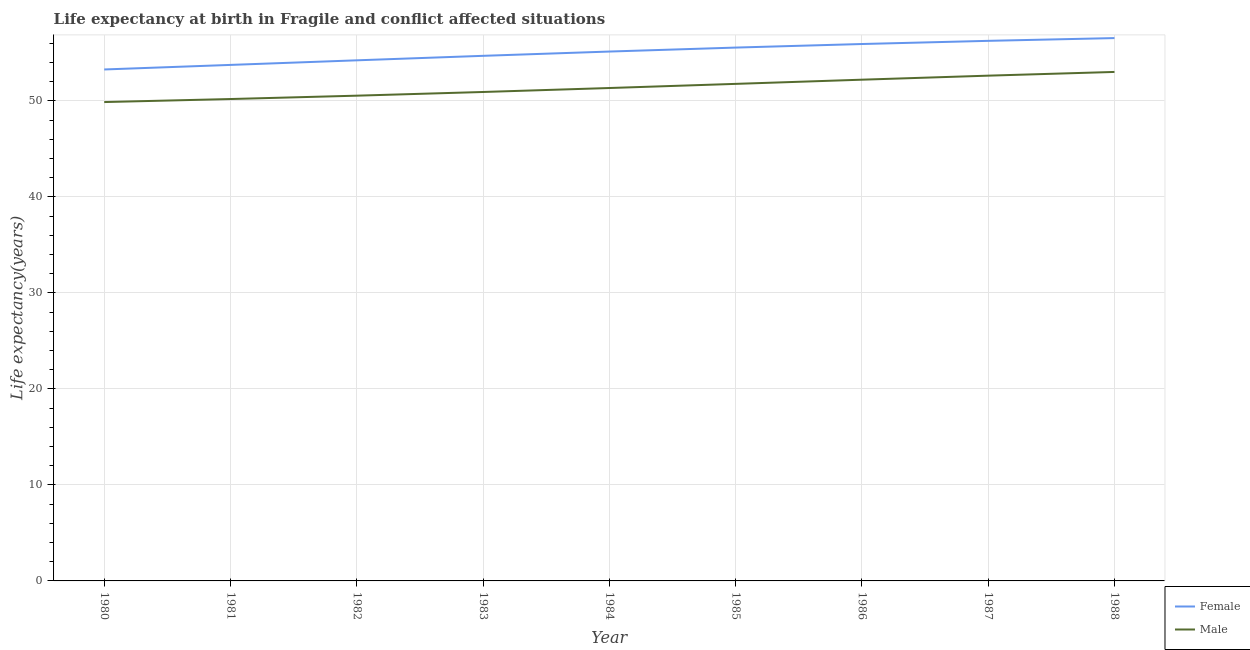How many different coloured lines are there?
Your answer should be very brief. 2. Is the number of lines equal to the number of legend labels?
Your answer should be compact. Yes. What is the life expectancy(female) in 1986?
Keep it short and to the point. 55.92. Across all years, what is the maximum life expectancy(male)?
Your response must be concise. 53.01. Across all years, what is the minimum life expectancy(male)?
Ensure brevity in your answer.  49.88. In which year was the life expectancy(male) maximum?
Your answer should be very brief. 1988. What is the total life expectancy(male) in the graph?
Keep it short and to the point. 462.5. What is the difference between the life expectancy(male) in 1980 and that in 1983?
Ensure brevity in your answer.  -1.05. What is the difference between the life expectancy(male) in 1988 and the life expectancy(female) in 1986?
Give a very brief answer. -2.91. What is the average life expectancy(female) per year?
Your response must be concise. 55.04. In the year 1981, what is the difference between the life expectancy(male) and life expectancy(female)?
Ensure brevity in your answer.  -3.55. In how many years, is the life expectancy(male) greater than 10 years?
Give a very brief answer. 9. What is the ratio of the life expectancy(male) in 1982 to that in 1985?
Your answer should be very brief. 0.98. Is the life expectancy(male) in 1983 less than that in 1988?
Your answer should be compact. Yes. What is the difference between the highest and the second highest life expectancy(female)?
Provide a succinct answer. 0.29. What is the difference between the highest and the lowest life expectancy(female)?
Provide a short and direct response. 3.27. In how many years, is the life expectancy(male) greater than the average life expectancy(male) taken over all years?
Make the answer very short. 4. Is the sum of the life expectancy(male) in 1980 and 1981 greater than the maximum life expectancy(female) across all years?
Offer a very short reply. Yes. Does the life expectancy(female) monotonically increase over the years?
Your response must be concise. Yes. Is the life expectancy(female) strictly greater than the life expectancy(male) over the years?
Keep it short and to the point. Yes. Is the life expectancy(male) strictly less than the life expectancy(female) over the years?
Your answer should be compact. Yes. Does the graph contain grids?
Make the answer very short. Yes. How are the legend labels stacked?
Make the answer very short. Vertical. What is the title of the graph?
Ensure brevity in your answer.  Life expectancy at birth in Fragile and conflict affected situations. What is the label or title of the X-axis?
Give a very brief answer. Year. What is the label or title of the Y-axis?
Provide a succinct answer. Life expectancy(years). What is the Life expectancy(years) of Female in 1980?
Your answer should be very brief. 53.27. What is the Life expectancy(years) of Male in 1980?
Your response must be concise. 49.88. What is the Life expectancy(years) in Female in 1981?
Give a very brief answer. 53.75. What is the Life expectancy(years) in Male in 1981?
Keep it short and to the point. 50.19. What is the Life expectancy(years) in Female in 1982?
Ensure brevity in your answer.  54.23. What is the Life expectancy(years) of Male in 1982?
Offer a terse response. 50.54. What is the Life expectancy(years) in Female in 1983?
Make the answer very short. 54.69. What is the Life expectancy(years) in Male in 1983?
Provide a short and direct response. 50.93. What is the Life expectancy(years) in Female in 1984?
Your answer should be compact. 55.14. What is the Life expectancy(years) of Male in 1984?
Make the answer very short. 51.34. What is the Life expectancy(years) of Female in 1985?
Offer a terse response. 55.55. What is the Life expectancy(years) of Male in 1985?
Keep it short and to the point. 51.77. What is the Life expectancy(years) of Female in 1986?
Provide a succinct answer. 55.92. What is the Life expectancy(years) in Male in 1986?
Your answer should be very brief. 52.21. What is the Life expectancy(years) in Female in 1987?
Ensure brevity in your answer.  56.25. What is the Life expectancy(years) of Male in 1987?
Make the answer very short. 52.63. What is the Life expectancy(years) in Female in 1988?
Ensure brevity in your answer.  56.54. What is the Life expectancy(years) of Male in 1988?
Offer a terse response. 53.01. Across all years, what is the maximum Life expectancy(years) of Female?
Ensure brevity in your answer.  56.54. Across all years, what is the maximum Life expectancy(years) in Male?
Offer a terse response. 53.01. Across all years, what is the minimum Life expectancy(years) in Female?
Make the answer very short. 53.27. Across all years, what is the minimum Life expectancy(years) in Male?
Make the answer very short. 49.88. What is the total Life expectancy(years) in Female in the graph?
Give a very brief answer. 495.35. What is the total Life expectancy(years) in Male in the graph?
Your answer should be very brief. 462.5. What is the difference between the Life expectancy(years) in Female in 1980 and that in 1981?
Your response must be concise. -0.48. What is the difference between the Life expectancy(years) in Male in 1980 and that in 1981?
Provide a short and direct response. -0.32. What is the difference between the Life expectancy(years) of Female in 1980 and that in 1982?
Offer a very short reply. -0.95. What is the difference between the Life expectancy(years) of Male in 1980 and that in 1982?
Keep it short and to the point. -0.67. What is the difference between the Life expectancy(years) of Female in 1980 and that in 1983?
Provide a succinct answer. -1.42. What is the difference between the Life expectancy(years) of Male in 1980 and that in 1983?
Your answer should be very brief. -1.05. What is the difference between the Life expectancy(years) of Female in 1980 and that in 1984?
Offer a terse response. -1.87. What is the difference between the Life expectancy(years) in Male in 1980 and that in 1984?
Make the answer very short. -1.46. What is the difference between the Life expectancy(years) in Female in 1980 and that in 1985?
Provide a succinct answer. -2.28. What is the difference between the Life expectancy(years) of Male in 1980 and that in 1985?
Make the answer very short. -1.9. What is the difference between the Life expectancy(years) in Female in 1980 and that in 1986?
Offer a very short reply. -2.65. What is the difference between the Life expectancy(years) of Male in 1980 and that in 1986?
Ensure brevity in your answer.  -2.33. What is the difference between the Life expectancy(years) of Female in 1980 and that in 1987?
Offer a very short reply. -2.98. What is the difference between the Life expectancy(years) of Male in 1980 and that in 1987?
Keep it short and to the point. -2.75. What is the difference between the Life expectancy(years) of Female in 1980 and that in 1988?
Make the answer very short. -3.27. What is the difference between the Life expectancy(years) in Male in 1980 and that in 1988?
Offer a terse response. -3.14. What is the difference between the Life expectancy(years) of Female in 1981 and that in 1982?
Give a very brief answer. -0.48. What is the difference between the Life expectancy(years) of Male in 1981 and that in 1982?
Offer a very short reply. -0.35. What is the difference between the Life expectancy(years) of Female in 1981 and that in 1983?
Offer a terse response. -0.95. What is the difference between the Life expectancy(years) of Male in 1981 and that in 1983?
Your answer should be very brief. -0.73. What is the difference between the Life expectancy(years) of Female in 1981 and that in 1984?
Your response must be concise. -1.39. What is the difference between the Life expectancy(years) of Male in 1981 and that in 1984?
Offer a very short reply. -1.15. What is the difference between the Life expectancy(years) in Female in 1981 and that in 1985?
Provide a succinct answer. -1.8. What is the difference between the Life expectancy(years) of Male in 1981 and that in 1985?
Make the answer very short. -1.58. What is the difference between the Life expectancy(years) of Female in 1981 and that in 1986?
Give a very brief answer. -2.18. What is the difference between the Life expectancy(years) in Male in 1981 and that in 1986?
Give a very brief answer. -2.01. What is the difference between the Life expectancy(years) in Female in 1981 and that in 1987?
Ensure brevity in your answer.  -2.51. What is the difference between the Life expectancy(years) in Male in 1981 and that in 1987?
Offer a terse response. -2.43. What is the difference between the Life expectancy(years) in Female in 1981 and that in 1988?
Offer a terse response. -2.79. What is the difference between the Life expectancy(years) in Male in 1981 and that in 1988?
Provide a succinct answer. -2.82. What is the difference between the Life expectancy(years) of Female in 1982 and that in 1983?
Your response must be concise. -0.47. What is the difference between the Life expectancy(years) of Male in 1982 and that in 1983?
Offer a terse response. -0.38. What is the difference between the Life expectancy(years) of Female in 1982 and that in 1984?
Offer a terse response. -0.91. What is the difference between the Life expectancy(years) in Male in 1982 and that in 1984?
Your answer should be compact. -0.8. What is the difference between the Life expectancy(years) in Female in 1982 and that in 1985?
Offer a terse response. -1.33. What is the difference between the Life expectancy(years) of Male in 1982 and that in 1985?
Keep it short and to the point. -1.23. What is the difference between the Life expectancy(years) of Female in 1982 and that in 1986?
Ensure brevity in your answer.  -1.7. What is the difference between the Life expectancy(years) of Male in 1982 and that in 1986?
Offer a terse response. -1.67. What is the difference between the Life expectancy(years) in Female in 1982 and that in 1987?
Provide a short and direct response. -2.03. What is the difference between the Life expectancy(years) of Male in 1982 and that in 1987?
Give a very brief answer. -2.09. What is the difference between the Life expectancy(years) in Female in 1982 and that in 1988?
Your answer should be very brief. -2.32. What is the difference between the Life expectancy(years) in Male in 1982 and that in 1988?
Give a very brief answer. -2.47. What is the difference between the Life expectancy(years) in Female in 1983 and that in 1984?
Provide a short and direct response. -0.45. What is the difference between the Life expectancy(years) in Male in 1983 and that in 1984?
Keep it short and to the point. -0.41. What is the difference between the Life expectancy(years) in Female in 1983 and that in 1985?
Your response must be concise. -0.86. What is the difference between the Life expectancy(years) of Male in 1983 and that in 1985?
Give a very brief answer. -0.85. What is the difference between the Life expectancy(years) in Female in 1983 and that in 1986?
Ensure brevity in your answer.  -1.23. What is the difference between the Life expectancy(years) of Male in 1983 and that in 1986?
Keep it short and to the point. -1.28. What is the difference between the Life expectancy(years) in Female in 1983 and that in 1987?
Offer a very short reply. -1.56. What is the difference between the Life expectancy(years) of Male in 1983 and that in 1987?
Give a very brief answer. -1.7. What is the difference between the Life expectancy(years) in Female in 1983 and that in 1988?
Keep it short and to the point. -1.85. What is the difference between the Life expectancy(years) in Male in 1983 and that in 1988?
Keep it short and to the point. -2.09. What is the difference between the Life expectancy(years) in Female in 1984 and that in 1985?
Keep it short and to the point. -0.41. What is the difference between the Life expectancy(years) in Male in 1984 and that in 1985?
Provide a short and direct response. -0.43. What is the difference between the Life expectancy(years) in Female in 1984 and that in 1986?
Your answer should be very brief. -0.78. What is the difference between the Life expectancy(years) of Male in 1984 and that in 1986?
Your response must be concise. -0.87. What is the difference between the Life expectancy(years) of Female in 1984 and that in 1987?
Give a very brief answer. -1.11. What is the difference between the Life expectancy(years) in Male in 1984 and that in 1987?
Ensure brevity in your answer.  -1.29. What is the difference between the Life expectancy(years) of Female in 1984 and that in 1988?
Give a very brief answer. -1.4. What is the difference between the Life expectancy(years) of Male in 1984 and that in 1988?
Your response must be concise. -1.67. What is the difference between the Life expectancy(years) of Female in 1985 and that in 1986?
Your response must be concise. -0.37. What is the difference between the Life expectancy(years) of Male in 1985 and that in 1986?
Your answer should be compact. -0.44. What is the difference between the Life expectancy(years) of Female in 1985 and that in 1987?
Your response must be concise. -0.7. What is the difference between the Life expectancy(years) in Male in 1985 and that in 1987?
Your response must be concise. -0.86. What is the difference between the Life expectancy(years) in Female in 1985 and that in 1988?
Offer a terse response. -0.99. What is the difference between the Life expectancy(years) in Male in 1985 and that in 1988?
Your answer should be compact. -1.24. What is the difference between the Life expectancy(years) in Female in 1986 and that in 1987?
Offer a very short reply. -0.33. What is the difference between the Life expectancy(years) in Male in 1986 and that in 1987?
Your answer should be compact. -0.42. What is the difference between the Life expectancy(years) of Female in 1986 and that in 1988?
Ensure brevity in your answer.  -0.62. What is the difference between the Life expectancy(years) of Male in 1986 and that in 1988?
Provide a succinct answer. -0.81. What is the difference between the Life expectancy(years) in Female in 1987 and that in 1988?
Your response must be concise. -0.29. What is the difference between the Life expectancy(years) in Male in 1987 and that in 1988?
Your response must be concise. -0.39. What is the difference between the Life expectancy(years) of Female in 1980 and the Life expectancy(years) of Male in 1981?
Keep it short and to the point. 3.08. What is the difference between the Life expectancy(years) of Female in 1980 and the Life expectancy(years) of Male in 1982?
Your response must be concise. 2.73. What is the difference between the Life expectancy(years) in Female in 1980 and the Life expectancy(years) in Male in 1983?
Keep it short and to the point. 2.35. What is the difference between the Life expectancy(years) of Female in 1980 and the Life expectancy(years) of Male in 1984?
Offer a very short reply. 1.93. What is the difference between the Life expectancy(years) of Female in 1980 and the Life expectancy(years) of Male in 1985?
Give a very brief answer. 1.5. What is the difference between the Life expectancy(years) in Female in 1980 and the Life expectancy(years) in Male in 1986?
Your answer should be compact. 1.06. What is the difference between the Life expectancy(years) of Female in 1980 and the Life expectancy(years) of Male in 1987?
Your answer should be very brief. 0.64. What is the difference between the Life expectancy(years) of Female in 1980 and the Life expectancy(years) of Male in 1988?
Keep it short and to the point. 0.26. What is the difference between the Life expectancy(years) of Female in 1981 and the Life expectancy(years) of Male in 1982?
Provide a short and direct response. 3.2. What is the difference between the Life expectancy(years) of Female in 1981 and the Life expectancy(years) of Male in 1983?
Provide a succinct answer. 2.82. What is the difference between the Life expectancy(years) of Female in 1981 and the Life expectancy(years) of Male in 1984?
Ensure brevity in your answer.  2.41. What is the difference between the Life expectancy(years) in Female in 1981 and the Life expectancy(years) in Male in 1985?
Your answer should be compact. 1.97. What is the difference between the Life expectancy(years) of Female in 1981 and the Life expectancy(years) of Male in 1986?
Keep it short and to the point. 1.54. What is the difference between the Life expectancy(years) in Female in 1981 and the Life expectancy(years) in Male in 1987?
Offer a very short reply. 1.12. What is the difference between the Life expectancy(years) in Female in 1981 and the Life expectancy(years) in Male in 1988?
Your answer should be very brief. 0.73. What is the difference between the Life expectancy(years) of Female in 1982 and the Life expectancy(years) of Male in 1983?
Ensure brevity in your answer.  3.3. What is the difference between the Life expectancy(years) of Female in 1982 and the Life expectancy(years) of Male in 1984?
Ensure brevity in your answer.  2.88. What is the difference between the Life expectancy(years) of Female in 1982 and the Life expectancy(years) of Male in 1985?
Your response must be concise. 2.45. What is the difference between the Life expectancy(years) in Female in 1982 and the Life expectancy(years) in Male in 1986?
Your answer should be compact. 2.02. What is the difference between the Life expectancy(years) of Female in 1982 and the Life expectancy(years) of Male in 1987?
Give a very brief answer. 1.6. What is the difference between the Life expectancy(years) of Female in 1982 and the Life expectancy(years) of Male in 1988?
Your answer should be compact. 1.21. What is the difference between the Life expectancy(years) in Female in 1983 and the Life expectancy(years) in Male in 1984?
Provide a short and direct response. 3.35. What is the difference between the Life expectancy(years) in Female in 1983 and the Life expectancy(years) in Male in 1985?
Your response must be concise. 2.92. What is the difference between the Life expectancy(years) of Female in 1983 and the Life expectancy(years) of Male in 1986?
Your answer should be very brief. 2.49. What is the difference between the Life expectancy(years) of Female in 1983 and the Life expectancy(years) of Male in 1987?
Ensure brevity in your answer.  2.07. What is the difference between the Life expectancy(years) in Female in 1983 and the Life expectancy(years) in Male in 1988?
Offer a terse response. 1.68. What is the difference between the Life expectancy(years) in Female in 1984 and the Life expectancy(years) in Male in 1985?
Ensure brevity in your answer.  3.37. What is the difference between the Life expectancy(years) in Female in 1984 and the Life expectancy(years) in Male in 1986?
Offer a terse response. 2.93. What is the difference between the Life expectancy(years) of Female in 1984 and the Life expectancy(years) of Male in 1987?
Provide a succinct answer. 2.51. What is the difference between the Life expectancy(years) in Female in 1984 and the Life expectancy(years) in Male in 1988?
Keep it short and to the point. 2.12. What is the difference between the Life expectancy(years) of Female in 1985 and the Life expectancy(years) of Male in 1986?
Keep it short and to the point. 3.34. What is the difference between the Life expectancy(years) in Female in 1985 and the Life expectancy(years) in Male in 1987?
Provide a succinct answer. 2.92. What is the difference between the Life expectancy(years) in Female in 1985 and the Life expectancy(years) in Male in 1988?
Provide a succinct answer. 2.54. What is the difference between the Life expectancy(years) in Female in 1986 and the Life expectancy(years) in Male in 1987?
Ensure brevity in your answer.  3.3. What is the difference between the Life expectancy(years) in Female in 1986 and the Life expectancy(years) in Male in 1988?
Provide a short and direct response. 2.91. What is the difference between the Life expectancy(years) in Female in 1987 and the Life expectancy(years) in Male in 1988?
Offer a terse response. 3.24. What is the average Life expectancy(years) of Female per year?
Provide a short and direct response. 55.04. What is the average Life expectancy(years) in Male per year?
Your answer should be compact. 51.39. In the year 1980, what is the difference between the Life expectancy(years) in Female and Life expectancy(years) in Male?
Ensure brevity in your answer.  3.4. In the year 1981, what is the difference between the Life expectancy(years) in Female and Life expectancy(years) in Male?
Offer a very short reply. 3.55. In the year 1982, what is the difference between the Life expectancy(years) of Female and Life expectancy(years) of Male?
Offer a terse response. 3.68. In the year 1983, what is the difference between the Life expectancy(years) of Female and Life expectancy(years) of Male?
Keep it short and to the point. 3.77. In the year 1984, what is the difference between the Life expectancy(years) in Female and Life expectancy(years) in Male?
Offer a very short reply. 3.8. In the year 1985, what is the difference between the Life expectancy(years) in Female and Life expectancy(years) in Male?
Provide a succinct answer. 3.78. In the year 1986, what is the difference between the Life expectancy(years) in Female and Life expectancy(years) in Male?
Your answer should be very brief. 3.72. In the year 1987, what is the difference between the Life expectancy(years) in Female and Life expectancy(years) in Male?
Your answer should be compact. 3.63. In the year 1988, what is the difference between the Life expectancy(years) of Female and Life expectancy(years) of Male?
Your response must be concise. 3.53. What is the ratio of the Life expectancy(years) of Female in 1980 to that in 1982?
Provide a succinct answer. 0.98. What is the ratio of the Life expectancy(years) of Male in 1980 to that in 1982?
Offer a terse response. 0.99. What is the ratio of the Life expectancy(years) in Male in 1980 to that in 1983?
Provide a short and direct response. 0.98. What is the ratio of the Life expectancy(years) in Female in 1980 to that in 1984?
Your response must be concise. 0.97. What is the ratio of the Life expectancy(years) of Male in 1980 to that in 1984?
Your response must be concise. 0.97. What is the ratio of the Life expectancy(years) in Male in 1980 to that in 1985?
Provide a short and direct response. 0.96. What is the ratio of the Life expectancy(years) in Female in 1980 to that in 1986?
Ensure brevity in your answer.  0.95. What is the ratio of the Life expectancy(years) in Male in 1980 to that in 1986?
Make the answer very short. 0.96. What is the ratio of the Life expectancy(years) of Female in 1980 to that in 1987?
Your response must be concise. 0.95. What is the ratio of the Life expectancy(years) of Male in 1980 to that in 1987?
Give a very brief answer. 0.95. What is the ratio of the Life expectancy(years) of Female in 1980 to that in 1988?
Your answer should be very brief. 0.94. What is the ratio of the Life expectancy(years) of Male in 1980 to that in 1988?
Ensure brevity in your answer.  0.94. What is the ratio of the Life expectancy(years) in Female in 1981 to that in 1983?
Make the answer very short. 0.98. What is the ratio of the Life expectancy(years) in Male in 1981 to that in 1983?
Your response must be concise. 0.99. What is the ratio of the Life expectancy(years) of Female in 1981 to that in 1984?
Offer a terse response. 0.97. What is the ratio of the Life expectancy(years) in Male in 1981 to that in 1984?
Your answer should be very brief. 0.98. What is the ratio of the Life expectancy(years) in Female in 1981 to that in 1985?
Make the answer very short. 0.97. What is the ratio of the Life expectancy(years) in Male in 1981 to that in 1985?
Your answer should be very brief. 0.97. What is the ratio of the Life expectancy(years) of Female in 1981 to that in 1986?
Keep it short and to the point. 0.96. What is the ratio of the Life expectancy(years) of Male in 1981 to that in 1986?
Your answer should be very brief. 0.96. What is the ratio of the Life expectancy(years) in Female in 1981 to that in 1987?
Offer a very short reply. 0.96. What is the ratio of the Life expectancy(years) of Male in 1981 to that in 1987?
Provide a short and direct response. 0.95. What is the ratio of the Life expectancy(years) in Female in 1981 to that in 1988?
Your response must be concise. 0.95. What is the ratio of the Life expectancy(years) of Male in 1981 to that in 1988?
Keep it short and to the point. 0.95. What is the ratio of the Life expectancy(years) in Male in 1982 to that in 1983?
Make the answer very short. 0.99. What is the ratio of the Life expectancy(years) in Female in 1982 to that in 1984?
Provide a succinct answer. 0.98. What is the ratio of the Life expectancy(years) in Male in 1982 to that in 1984?
Offer a terse response. 0.98. What is the ratio of the Life expectancy(years) of Female in 1982 to that in 1985?
Offer a terse response. 0.98. What is the ratio of the Life expectancy(years) of Male in 1982 to that in 1985?
Ensure brevity in your answer.  0.98. What is the ratio of the Life expectancy(years) of Female in 1982 to that in 1986?
Provide a succinct answer. 0.97. What is the ratio of the Life expectancy(years) in Male in 1982 to that in 1986?
Offer a terse response. 0.97. What is the ratio of the Life expectancy(years) of Female in 1982 to that in 1987?
Keep it short and to the point. 0.96. What is the ratio of the Life expectancy(years) of Male in 1982 to that in 1987?
Give a very brief answer. 0.96. What is the ratio of the Life expectancy(years) in Female in 1982 to that in 1988?
Your answer should be very brief. 0.96. What is the ratio of the Life expectancy(years) of Male in 1982 to that in 1988?
Offer a very short reply. 0.95. What is the ratio of the Life expectancy(years) in Female in 1983 to that in 1984?
Offer a very short reply. 0.99. What is the ratio of the Life expectancy(years) in Female in 1983 to that in 1985?
Provide a short and direct response. 0.98. What is the ratio of the Life expectancy(years) in Male in 1983 to that in 1985?
Ensure brevity in your answer.  0.98. What is the ratio of the Life expectancy(years) in Male in 1983 to that in 1986?
Your answer should be compact. 0.98. What is the ratio of the Life expectancy(years) of Female in 1983 to that in 1987?
Offer a terse response. 0.97. What is the ratio of the Life expectancy(years) in Female in 1983 to that in 1988?
Give a very brief answer. 0.97. What is the ratio of the Life expectancy(years) of Male in 1983 to that in 1988?
Your answer should be very brief. 0.96. What is the ratio of the Life expectancy(years) of Female in 1984 to that in 1986?
Make the answer very short. 0.99. What is the ratio of the Life expectancy(years) in Male in 1984 to that in 1986?
Keep it short and to the point. 0.98. What is the ratio of the Life expectancy(years) of Female in 1984 to that in 1987?
Offer a very short reply. 0.98. What is the ratio of the Life expectancy(years) in Male in 1984 to that in 1987?
Give a very brief answer. 0.98. What is the ratio of the Life expectancy(years) in Female in 1984 to that in 1988?
Give a very brief answer. 0.98. What is the ratio of the Life expectancy(years) of Male in 1984 to that in 1988?
Your answer should be compact. 0.97. What is the ratio of the Life expectancy(years) of Female in 1985 to that in 1987?
Ensure brevity in your answer.  0.99. What is the ratio of the Life expectancy(years) in Male in 1985 to that in 1987?
Provide a succinct answer. 0.98. What is the ratio of the Life expectancy(years) in Female in 1985 to that in 1988?
Give a very brief answer. 0.98. What is the ratio of the Life expectancy(years) of Male in 1985 to that in 1988?
Provide a short and direct response. 0.98. What is the ratio of the Life expectancy(years) in Male in 1986 to that in 1988?
Provide a short and direct response. 0.98. What is the difference between the highest and the second highest Life expectancy(years) of Female?
Your answer should be very brief. 0.29. What is the difference between the highest and the second highest Life expectancy(years) of Male?
Your response must be concise. 0.39. What is the difference between the highest and the lowest Life expectancy(years) in Female?
Your answer should be very brief. 3.27. What is the difference between the highest and the lowest Life expectancy(years) in Male?
Offer a terse response. 3.14. 